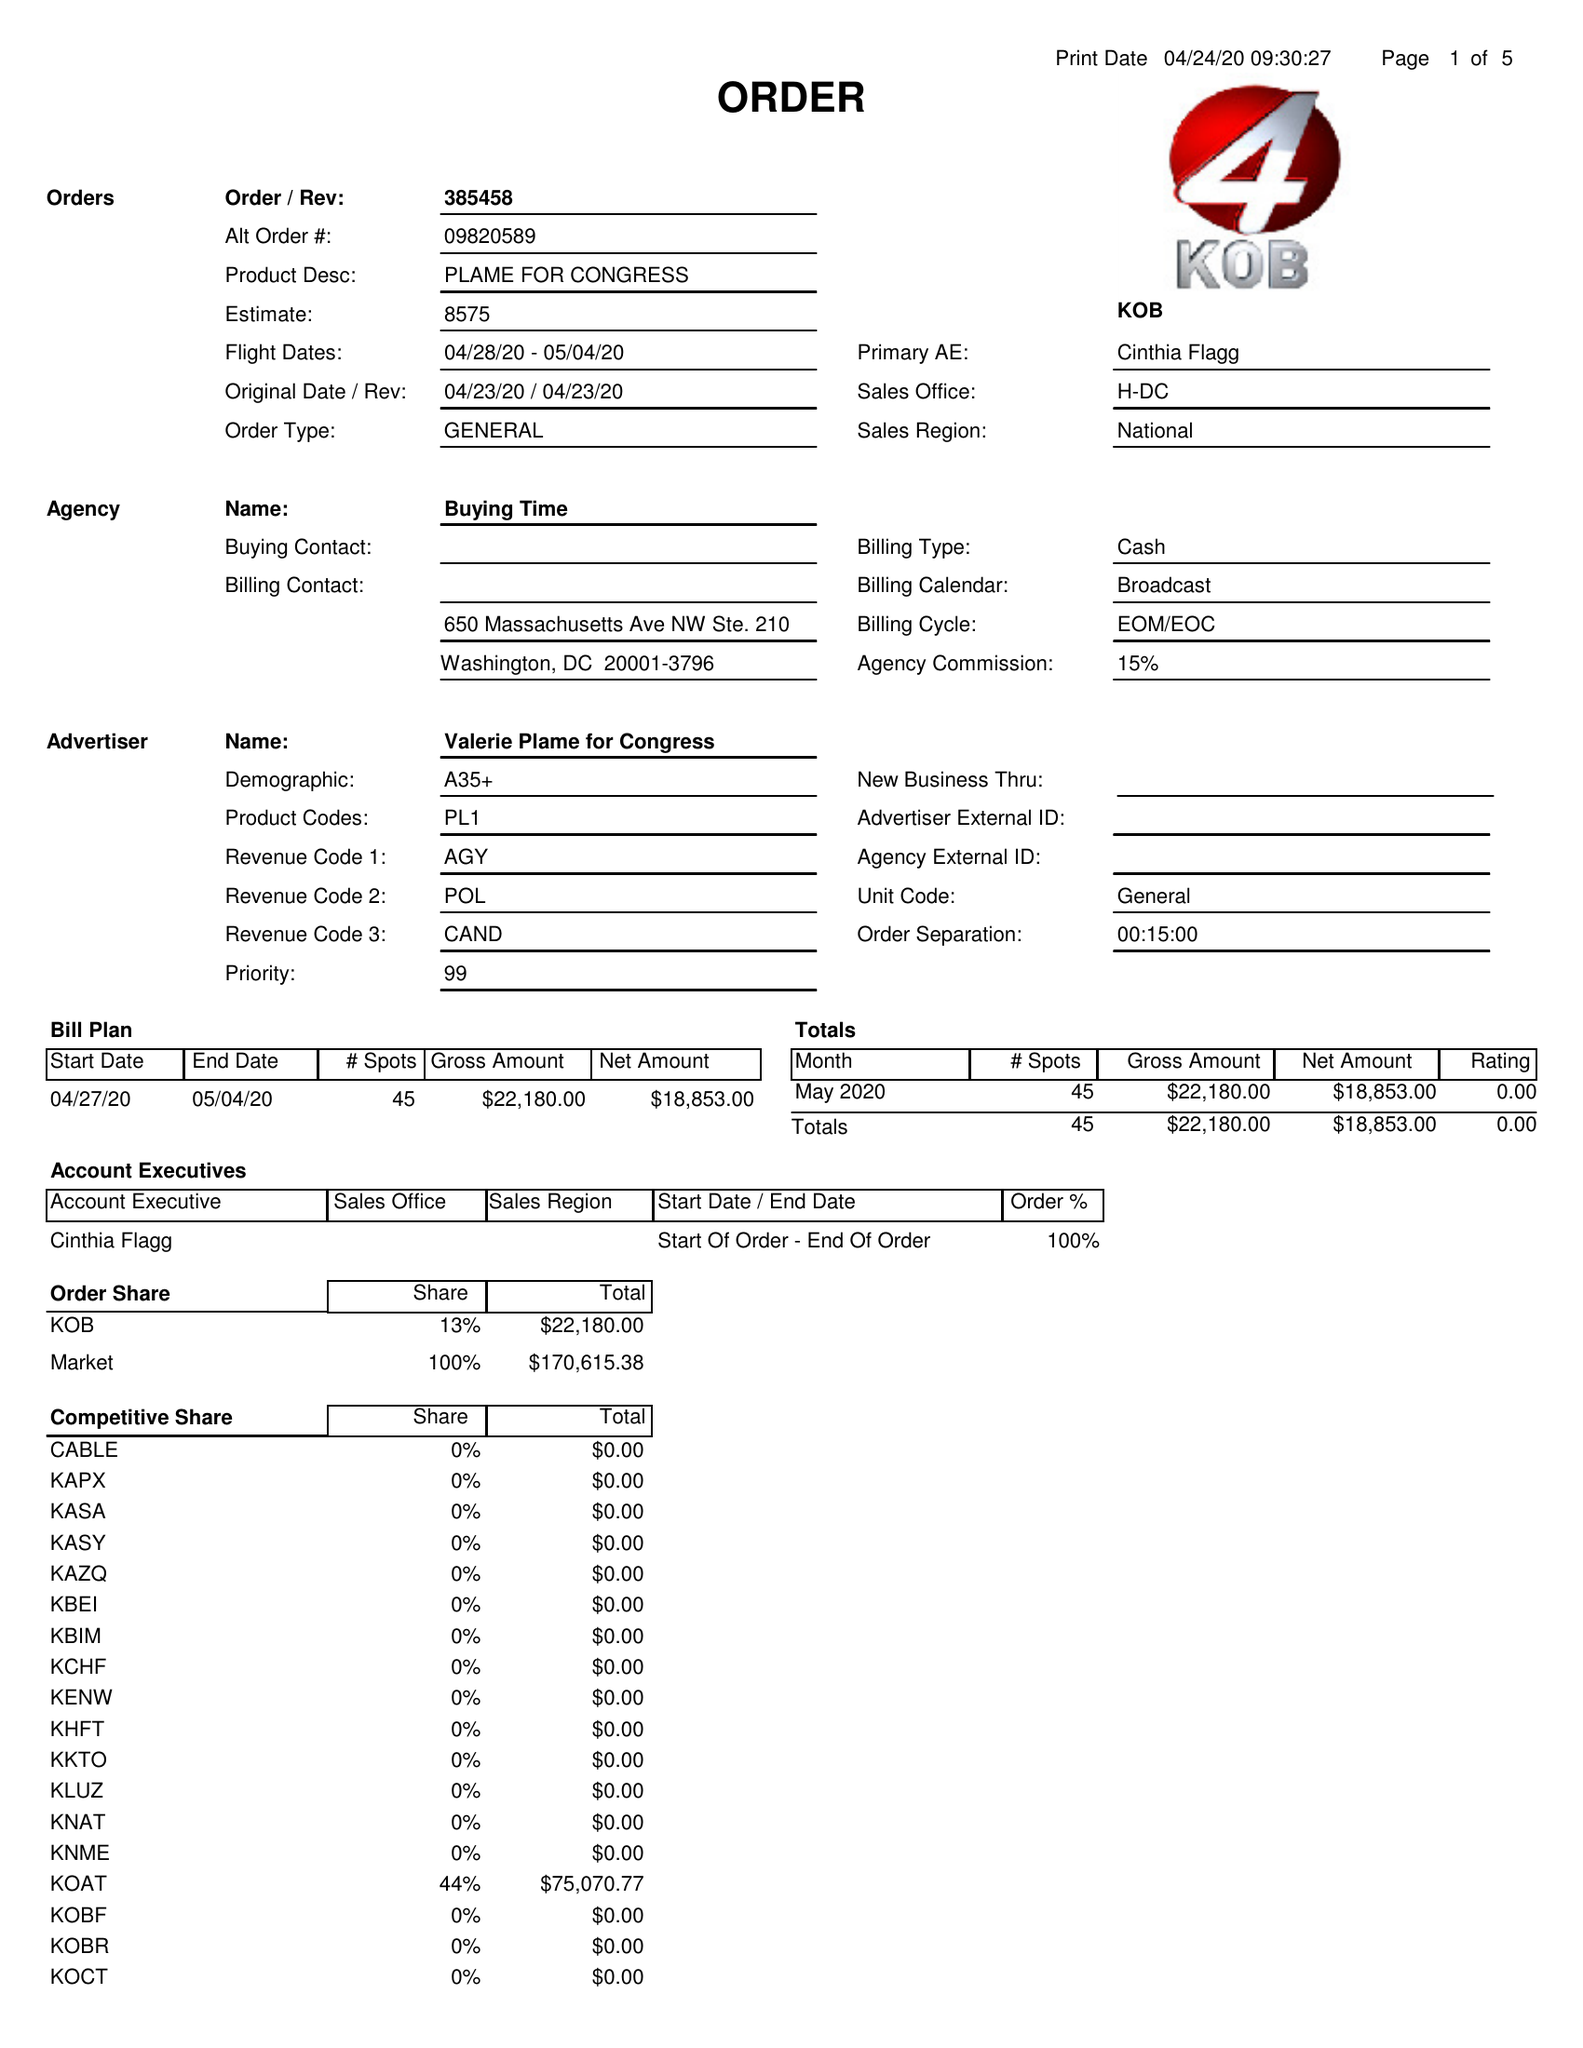What is the value for the advertiser?
Answer the question using a single word or phrase. VALERIE PLAME FOR CONGRESS 